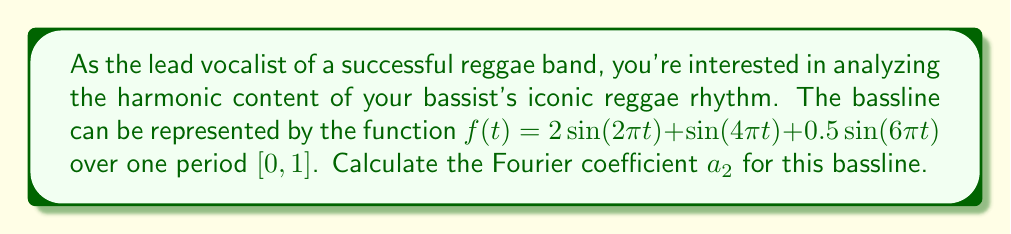Show me your answer to this math problem. To find the Fourier coefficient $a_2$, we need to use the Fourier series formula for $a_n$:

$$a_n = 2\int_0^1 f(t)\cos(2\pi nt)dt$$

For $a_2$, we substitute $n=2$:

$$a_2 = 2\int_0^1 [2\sin(2\pi t) + \sin(4\pi t) + 0.5\sin(6\pi t)]\cos(4\pi t)dt$$

Let's break this down into three integrals:

1) $I_1 = 4\int_0^1 \sin(2\pi t)\cos(4\pi t)dt$
2) $I_2 = 2\int_0^1 \sin(4\pi t)\cos(4\pi t)dt$
3) $I_3 = \int_0^1 \sin(6\pi t)\cos(4\pi t)dt$

For $I_1$, we can use the trigonometric identity:
$\sin A \cos B = \frac{1}{2}[\sin(A-B) + \sin(A+B)]$

$$I_1 = 4\int_0^1 \frac{1}{2}[\sin(-2\pi t) + \sin(6\pi t)]dt = 2\int_0^1 [-\sin(2\pi t) + \sin(6\pi t)]dt$$

$$I_1 = 2[\frac{\cos(2\pi t)}{2\pi} - \frac{\cos(6\pi t)}{6\pi}]_0^1 = 0$$

For $I_2$, we use the identity $\sin A \cos A = \frac{1}{2}\sin(2A)$:

$$I_2 = 2\int_0^1 \frac{1}{2}\sin(8\pi t)dt = [\frac{-\cos(8\pi t)}{8\pi}]_0^1 = 0$$

For $I_3$, we use the same identity as in $I_1$:

$$I_3 = \int_0^1 \frac{1}{2}[\sin(2\pi t) + \sin(10\pi t)]dt = [\frac{-\cos(2\pi t)}{4\pi} - \frac{\cos(10\pi t)}{20\pi}]_0^1 = 0$$

Therefore, $a_2 = I_1 + I_2 + I_3 = 0 + 0 + 0 = 0$
Answer: $a_2 = 0$ 